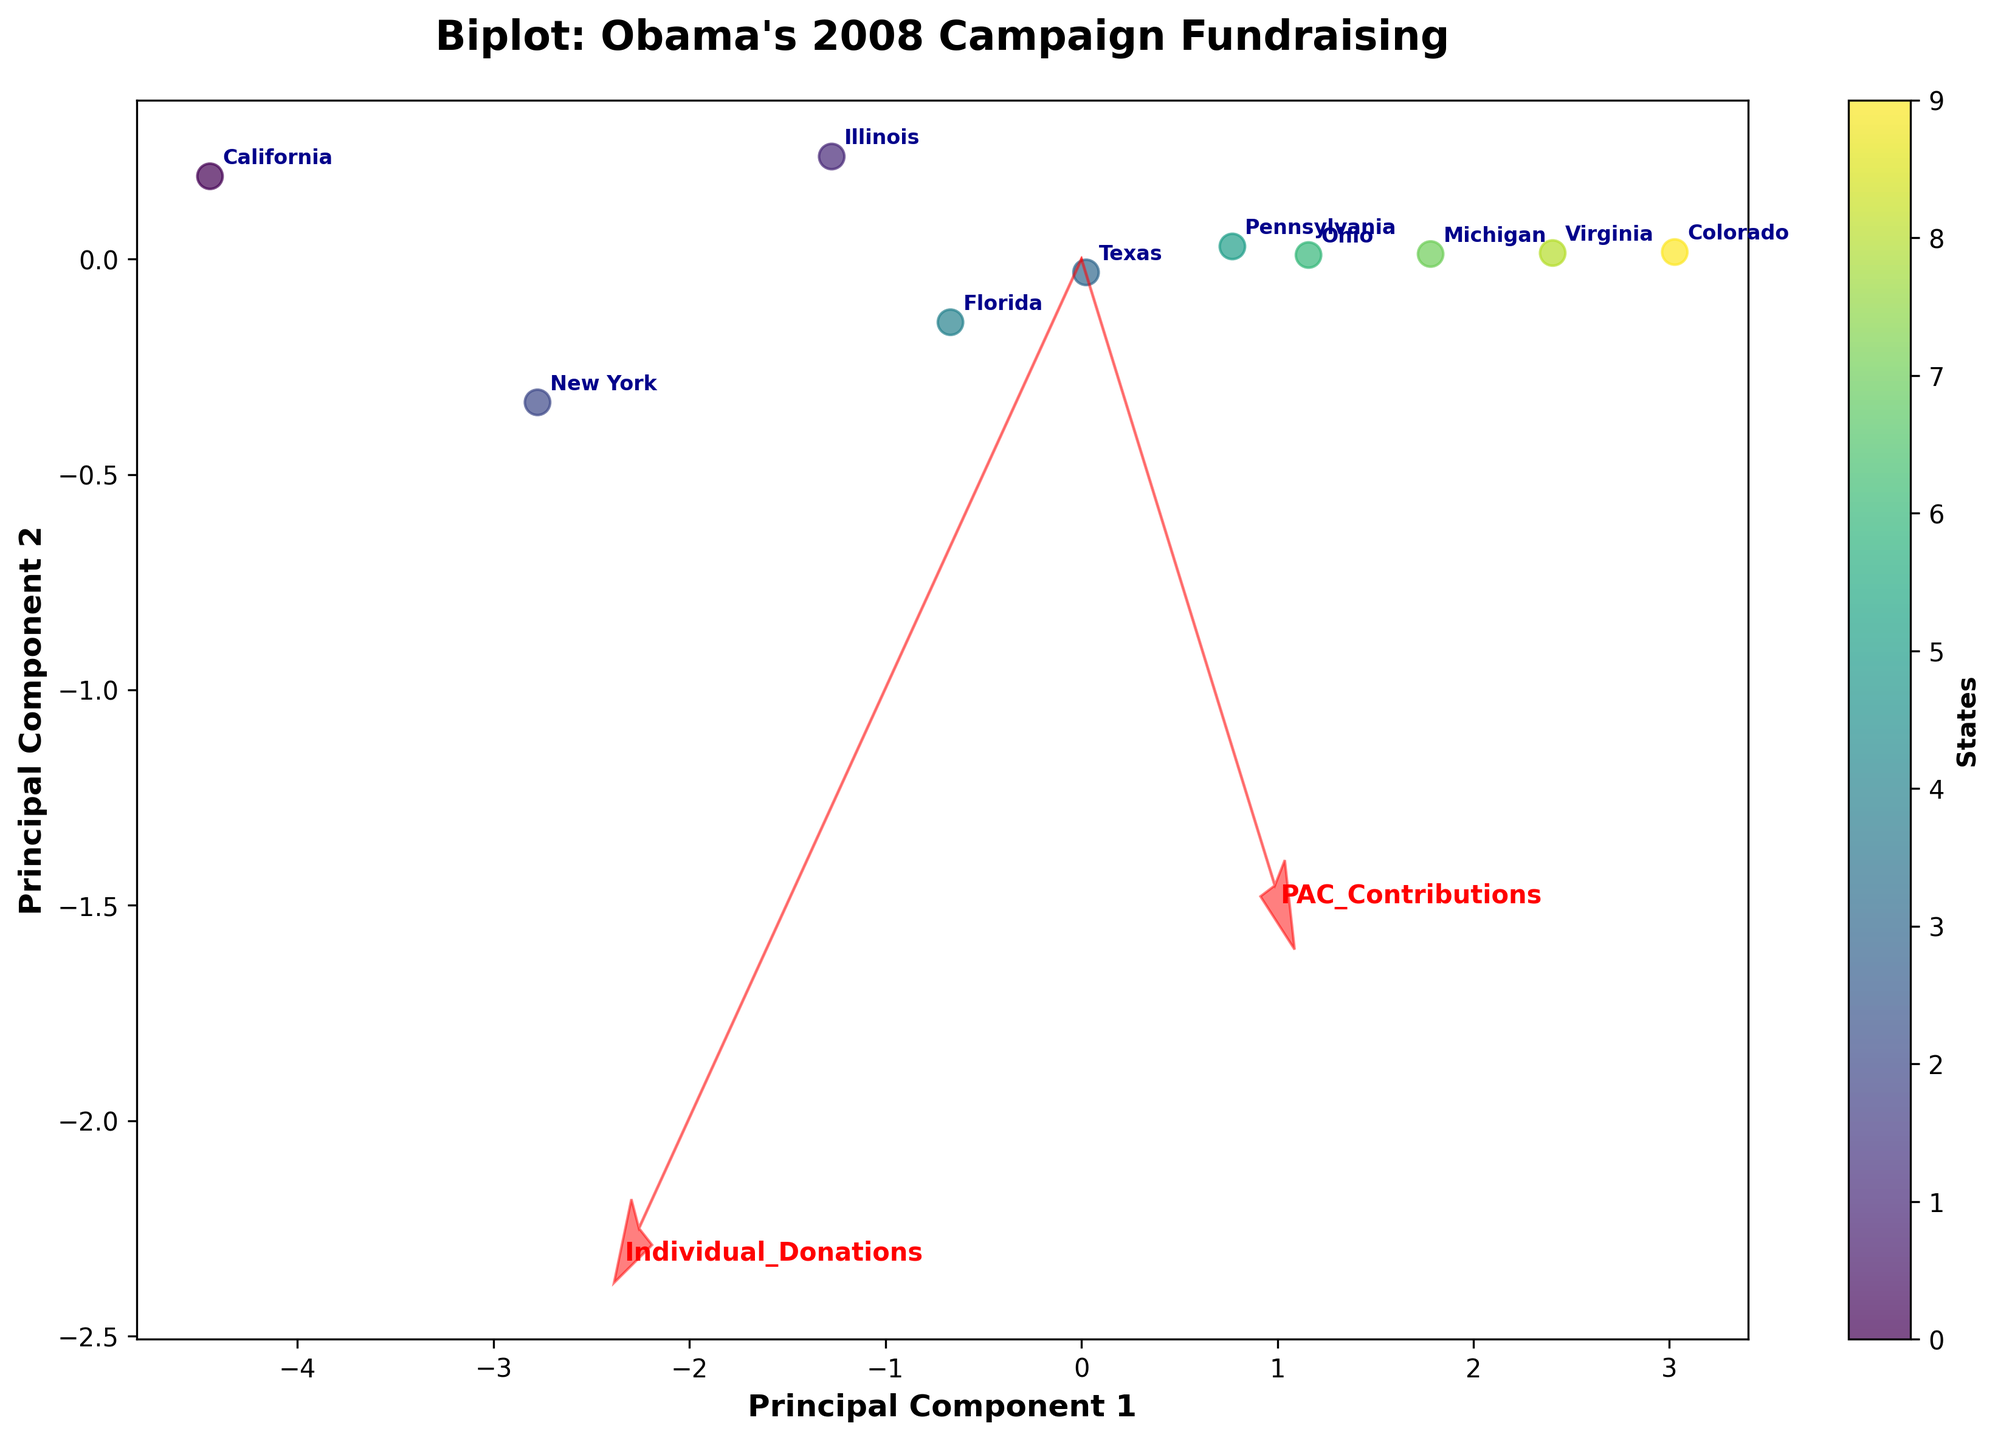How many states are represented in the biplot? By counting the number of unique labels on the plot, we can determine the number of states represented.
Answer: 10 What does Principal Component 1 represent? Principal Component 1 is the primary axis on the horizontal direction, representing the direction with the maximal variance in the data set. It captures the most significant trends across the various fundraising sources.
Answer: Maximal variance direction Which state has the highest value along Principal Component 2? By observing the vertical axis (Principal Component 2), we look for the state label positioned the highest.
Answer: Pennsylvania Between California and New York, which state is positioned closer to the origin? By comparing the proximity of the labels "California" and "New York" to the center of the plot (origin), we can determine which is closer.
Answer: New York Which fundraising source contributes most to Principal Component 1? By observing the red arrows originating from the origin, we identify the arrow pointing most significantly in the horizontal direction (Principal Component 1).
Answer: Individual Donations What relationship can be drawn between Texas and Ohio in terms of their fundraising composition? By locating Texas and Ohio on the biplot, we take note of their relative positions and the red arrows indicating the direction of various fundraising sources.
Answer: Texas and Ohio have similar compositions, both strongly influenced by Individual Donations How does the variance in PAC Contributions compare across the states? By observing the length and direction of the red arrow representing PAC Contributions, we can infer that a shorter arrow means less variance.
Answer: Low compared to sources like Individual Donations Which states appear to be most similar in their fundraising profiles? By identifying states that cluster closely together on the biplot, we can determine which ones have similar fundraising profiles. For instance, Illinois and Florida are close together.
Answer: Illinois and Florida What can be inferred about Michigan's online fundraising efforts based on its position on the biplot? By looking at Michigan's position relative to the Online Fundraising arrow, we see if it is aligned or in close proximity, inferring its fundraising strength in this area.
Answer: Moderate How are Grassroots Events represented in the biplot and which state aligns closely with this fundraising activity? Observing the red arrow labeled "Grassroots Events", we note its direction and the closeness of the states to this vector.
Answer: Pennsylvania 